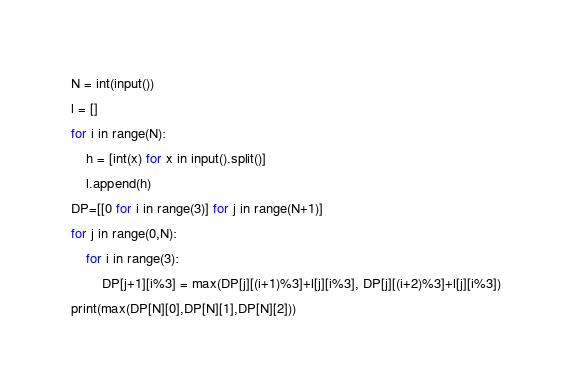<code> <loc_0><loc_0><loc_500><loc_500><_Python_>N = int(input())
l = []
for i in range(N):
    h = [int(x) for x in input().split()]
    l.append(h)
DP=[[0 for i in range(3)] for j in range(N+1)]
for j in range(0,N):
    for i in range(3):
        DP[j+1][i%3] = max(DP[j][(i+1)%3]+l[j][i%3], DP[j][(i+2)%3]+l[j][i%3])
print(max(DP[N][0],DP[N][1],DP[N][2]))</code> 